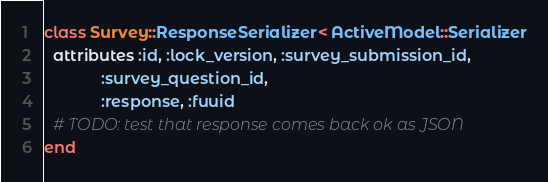Convert code to text. <code><loc_0><loc_0><loc_500><loc_500><_Ruby_>class Survey::ResponseSerializer < ActiveModel::Serializer
  attributes :id, :lock_version, :survey_submission_id,
             :survey_question_id,
             :response, :fuuid
  # TODO: test that response comes back ok as JSON
end
</code> 